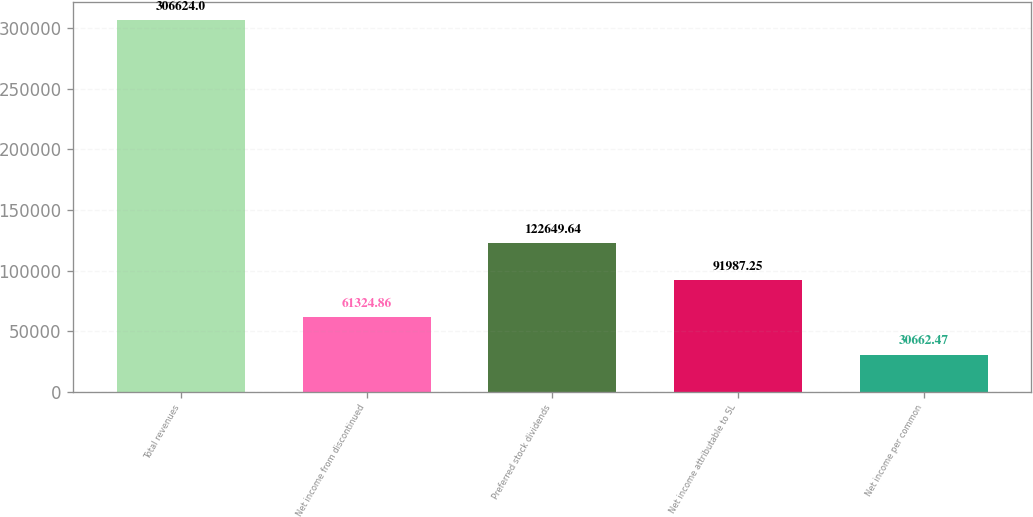Convert chart. <chart><loc_0><loc_0><loc_500><loc_500><bar_chart><fcel>Total revenues<fcel>Net income from discontinued<fcel>Preferred stock dividends<fcel>Net income attributable to SL<fcel>Net income per common<nl><fcel>306624<fcel>61324.9<fcel>122650<fcel>91987.2<fcel>30662.5<nl></chart> 